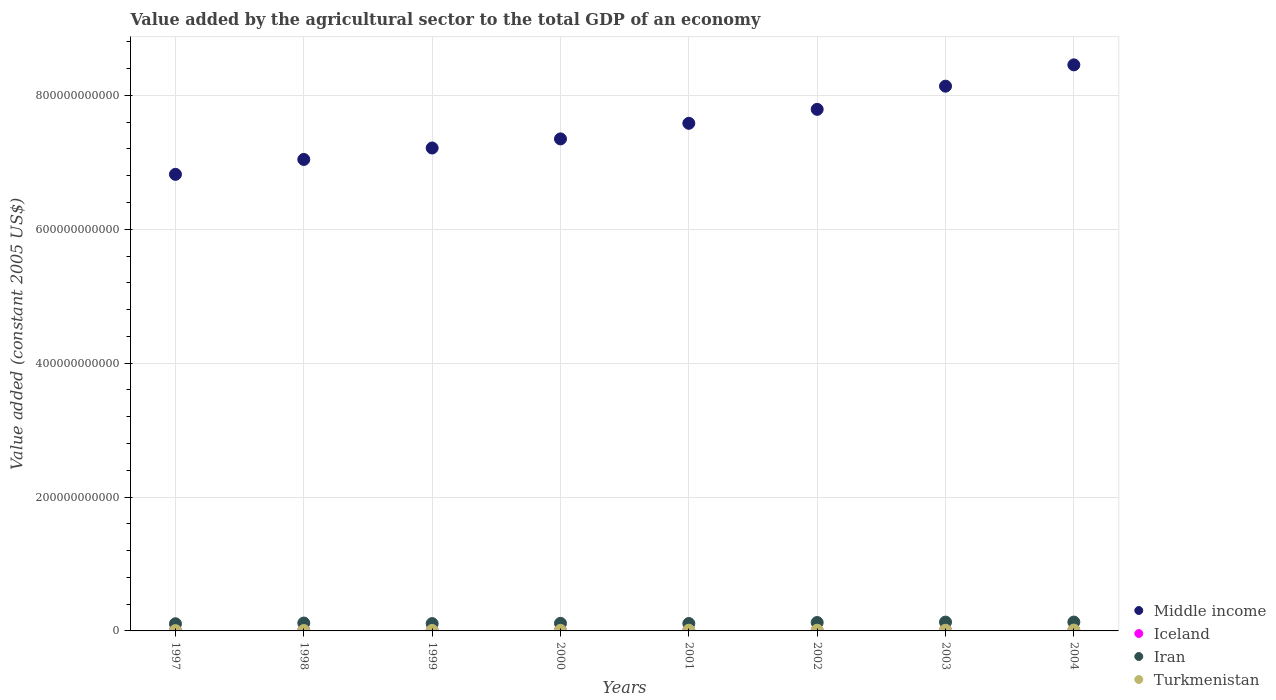How many different coloured dotlines are there?
Make the answer very short. 4. Is the number of dotlines equal to the number of legend labels?
Your answer should be very brief. Yes. What is the value added by the agricultural sector in Turkmenistan in 1999?
Provide a short and direct response. 7.26e+08. Across all years, what is the maximum value added by the agricultural sector in Middle income?
Your answer should be very brief. 8.46e+11. Across all years, what is the minimum value added by the agricultural sector in Iceland?
Your answer should be very brief. 7.81e+08. In which year was the value added by the agricultural sector in Iceland minimum?
Provide a succinct answer. 2000. What is the total value added by the agricultural sector in Turkmenistan in the graph?
Give a very brief answer. 7.00e+09. What is the difference between the value added by the agricultural sector in Iran in 1997 and that in 2003?
Offer a very short reply. -2.51e+09. What is the difference between the value added by the agricultural sector in Turkmenistan in 1998 and the value added by the agricultural sector in Iran in 2000?
Ensure brevity in your answer.  -1.07e+1. What is the average value added by the agricultural sector in Turkmenistan per year?
Your answer should be compact. 8.75e+08. In the year 2000, what is the difference between the value added by the agricultural sector in Iran and value added by the agricultural sector in Turkmenistan?
Your answer should be compact. 1.05e+1. In how many years, is the value added by the agricultural sector in Iceland greater than 480000000000 US$?
Keep it short and to the point. 0. What is the ratio of the value added by the agricultural sector in Turkmenistan in 1997 to that in 2001?
Ensure brevity in your answer.  0.45. What is the difference between the highest and the second highest value added by the agricultural sector in Iran?
Your answer should be very brief. 4.16e+07. What is the difference between the highest and the lowest value added by the agricultural sector in Iceland?
Your answer should be very brief. 8.22e+07. In how many years, is the value added by the agricultural sector in Iran greater than the average value added by the agricultural sector in Iran taken over all years?
Your answer should be very brief. 3. Is the sum of the value added by the agricultural sector in Iran in 1998 and 2003 greater than the maximum value added by the agricultural sector in Middle income across all years?
Give a very brief answer. No. Is it the case that in every year, the sum of the value added by the agricultural sector in Middle income and value added by the agricultural sector in Iceland  is greater than the sum of value added by the agricultural sector in Turkmenistan and value added by the agricultural sector in Iran?
Offer a very short reply. Yes. Is the value added by the agricultural sector in Iceland strictly greater than the value added by the agricultural sector in Turkmenistan over the years?
Provide a short and direct response. No. How many dotlines are there?
Offer a very short reply. 4. How many years are there in the graph?
Make the answer very short. 8. What is the difference between two consecutive major ticks on the Y-axis?
Offer a very short reply. 2.00e+11. Are the values on the major ticks of Y-axis written in scientific E-notation?
Provide a succinct answer. No. Where does the legend appear in the graph?
Provide a short and direct response. Bottom right. How many legend labels are there?
Your answer should be compact. 4. What is the title of the graph?
Keep it short and to the point. Value added by the agricultural sector to the total GDP of an economy. What is the label or title of the Y-axis?
Ensure brevity in your answer.  Value added (constant 2005 US$). What is the Value added (constant 2005 US$) of Middle income in 1997?
Make the answer very short. 6.82e+11. What is the Value added (constant 2005 US$) in Iceland in 1997?
Keep it short and to the point. 8.63e+08. What is the Value added (constant 2005 US$) in Iran in 1997?
Your response must be concise. 1.07e+1. What is the Value added (constant 2005 US$) in Turkmenistan in 1997?
Provide a succinct answer. 4.65e+08. What is the Value added (constant 2005 US$) of Middle income in 1998?
Your answer should be compact. 7.04e+11. What is the Value added (constant 2005 US$) of Iceland in 1998?
Ensure brevity in your answer.  8.18e+08. What is the Value added (constant 2005 US$) of Iran in 1998?
Ensure brevity in your answer.  1.18e+1. What is the Value added (constant 2005 US$) in Turkmenistan in 1998?
Your response must be concise. 5.78e+08. What is the Value added (constant 2005 US$) in Middle income in 1999?
Give a very brief answer. 7.21e+11. What is the Value added (constant 2005 US$) in Iceland in 1999?
Provide a short and direct response. 7.97e+08. What is the Value added (constant 2005 US$) of Iran in 1999?
Give a very brief answer. 1.09e+1. What is the Value added (constant 2005 US$) in Turkmenistan in 1999?
Your answer should be compact. 7.26e+08. What is the Value added (constant 2005 US$) of Middle income in 2000?
Offer a terse response. 7.35e+11. What is the Value added (constant 2005 US$) of Iceland in 2000?
Offer a very short reply. 7.81e+08. What is the Value added (constant 2005 US$) in Iran in 2000?
Provide a short and direct response. 1.13e+1. What is the Value added (constant 2005 US$) in Turkmenistan in 2000?
Provide a short and direct response. 8.49e+08. What is the Value added (constant 2005 US$) in Middle income in 2001?
Provide a short and direct response. 7.58e+11. What is the Value added (constant 2005 US$) in Iceland in 2001?
Your answer should be very brief. 7.92e+08. What is the Value added (constant 2005 US$) of Iran in 2001?
Your answer should be very brief. 1.11e+1. What is the Value added (constant 2005 US$) of Turkmenistan in 2001?
Offer a very short reply. 1.04e+09. What is the Value added (constant 2005 US$) of Middle income in 2002?
Ensure brevity in your answer.  7.79e+11. What is the Value added (constant 2005 US$) of Iceland in 2002?
Keep it short and to the point. 8.12e+08. What is the Value added (constant 2005 US$) of Iran in 2002?
Offer a very short reply. 1.26e+1. What is the Value added (constant 2005 US$) of Turkmenistan in 2002?
Offer a terse response. 1.05e+09. What is the Value added (constant 2005 US$) in Middle income in 2003?
Provide a succinct answer. 8.14e+11. What is the Value added (constant 2005 US$) in Iceland in 2003?
Provide a short and direct response. 7.88e+08. What is the Value added (constant 2005 US$) in Iran in 2003?
Ensure brevity in your answer.  1.32e+1. What is the Value added (constant 2005 US$) of Turkmenistan in 2003?
Your answer should be very brief. 1.05e+09. What is the Value added (constant 2005 US$) of Middle income in 2004?
Give a very brief answer. 8.46e+11. What is the Value added (constant 2005 US$) of Iceland in 2004?
Provide a short and direct response. 8.17e+08. What is the Value added (constant 2005 US$) of Iran in 2004?
Provide a short and direct response. 1.32e+1. What is the Value added (constant 2005 US$) of Turkmenistan in 2004?
Provide a short and direct response. 1.25e+09. Across all years, what is the maximum Value added (constant 2005 US$) in Middle income?
Offer a terse response. 8.46e+11. Across all years, what is the maximum Value added (constant 2005 US$) of Iceland?
Your answer should be very brief. 8.63e+08. Across all years, what is the maximum Value added (constant 2005 US$) in Iran?
Ensure brevity in your answer.  1.32e+1. Across all years, what is the maximum Value added (constant 2005 US$) in Turkmenistan?
Provide a short and direct response. 1.25e+09. Across all years, what is the minimum Value added (constant 2005 US$) in Middle income?
Provide a succinct answer. 6.82e+11. Across all years, what is the minimum Value added (constant 2005 US$) in Iceland?
Make the answer very short. 7.81e+08. Across all years, what is the minimum Value added (constant 2005 US$) in Iran?
Your answer should be compact. 1.07e+1. Across all years, what is the minimum Value added (constant 2005 US$) in Turkmenistan?
Ensure brevity in your answer.  4.65e+08. What is the total Value added (constant 2005 US$) in Middle income in the graph?
Keep it short and to the point. 6.04e+12. What is the total Value added (constant 2005 US$) of Iceland in the graph?
Make the answer very short. 6.47e+09. What is the total Value added (constant 2005 US$) of Iran in the graph?
Give a very brief answer. 9.48e+1. What is the total Value added (constant 2005 US$) in Turkmenistan in the graph?
Your response must be concise. 7.00e+09. What is the difference between the Value added (constant 2005 US$) of Middle income in 1997 and that in 1998?
Make the answer very short. -2.23e+1. What is the difference between the Value added (constant 2005 US$) in Iceland in 1997 and that in 1998?
Make the answer very short. 4.45e+07. What is the difference between the Value added (constant 2005 US$) in Iran in 1997 and that in 1998?
Provide a short and direct response. -1.13e+09. What is the difference between the Value added (constant 2005 US$) in Turkmenistan in 1997 and that in 1998?
Provide a short and direct response. -1.13e+08. What is the difference between the Value added (constant 2005 US$) in Middle income in 1997 and that in 1999?
Offer a very short reply. -3.94e+1. What is the difference between the Value added (constant 2005 US$) in Iceland in 1997 and that in 1999?
Keep it short and to the point. 6.59e+07. What is the difference between the Value added (constant 2005 US$) of Iran in 1997 and that in 1999?
Offer a very short reply. -2.66e+08. What is the difference between the Value added (constant 2005 US$) of Turkmenistan in 1997 and that in 1999?
Keep it short and to the point. -2.61e+08. What is the difference between the Value added (constant 2005 US$) of Middle income in 1997 and that in 2000?
Your response must be concise. -5.30e+1. What is the difference between the Value added (constant 2005 US$) in Iceland in 1997 and that in 2000?
Keep it short and to the point. 8.22e+07. What is the difference between the Value added (constant 2005 US$) in Iran in 1997 and that in 2000?
Make the answer very short. -6.46e+08. What is the difference between the Value added (constant 2005 US$) of Turkmenistan in 1997 and that in 2000?
Offer a very short reply. -3.84e+08. What is the difference between the Value added (constant 2005 US$) of Middle income in 1997 and that in 2001?
Offer a very short reply. -7.62e+1. What is the difference between the Value added (constant 2005 US$) of Iceland in 1997 and that in 2001?
Provide a short and direct response. 7.13e+07. What is the difference between the Value added (constant 2005 US$) in Iran in 1997 and that in 2001?
Ensure brevity in your answer.  -3.90e+08. What is the difference between the Value added (constant 2005 US$) in Turkmenistan in 1997 and that in 2001?
Ensure brevity in your answer.  -5.80e+08. What is the difference between the Value added (constant 2005 US$) in Middle income in 1997 and that in 2002?
Offer a very short reply. -9.71e+1. What is the difference between the Value added (constant 2005 US$) of Iceland in 1997 and that in 2002?
Your answer should be very brief. 5.09e+07. What is the difference between the Value added (constant 2005 US$) of Iran in 1997 and that in 2002?
Keep it short and to the point. -1.89e+09. What is the difference between the Value added (constant 2005 US$) of Turkmenistan in 1997 and that in 2002?
Your response must be concise. -5.81e+08. What is the difference between the Value added (constant 2005 US$) of Middle income in 1997 and that in 2003?
Provide a succinct answer. -1.32e+11. What is the difference between the Value added (constant 2005 US$) in Iceland in 1997 and that in 2003?
Offer a terse response. 7.52e+07. What is the difference between the Value added (constant 2005 US$) in Iran in 1997 and that in 2003?
Ensure brevity in your answer.  -2.51e+09. What is the difference between the Value added (constant 2005 US$) of Turkmenistan in 1997 and that in 2003?
Provide a short and direct response. -5.82e+08. What is the difference between the Value added (constant 2005 US$) in Middle income in 1997 and that in 2004?
Ensure brevity in your answer.  -1.64e+11. What is the difference between the Value added (constant 2005 US$) of Iceland in 1997 and that in 2004?
Ensure brevity in your answer.  4.60e+07. What is the difference between the Value added (constant 2005 US$) in Iran in 1997 and that in 2004?
Your response must be concise. -2.55e+09. What is the difference between the Value added (constant 2005 US$) in Turkmenistan in 1997 and that in 2004?
Your answer should be compact. -7.84e+08. What is the difference between the Value added (constant 2005 US$) of Middle income in 1998 and that in 1999?
Keep it short and to the point. -1.71e+1. What is the difference between the Value added (constant 2005 US$) of Iceland in 1998 and that in 1999?
Your response must be concise. 2.15e+07. What is the difference between the Value added (constant 2005 US$) of Iran in 1998 and that in 1999?
Your answer should be compact. 8.62e+08. What is the difference between the Value added (constant 2005 US$) in Turkmenistan in 1998 and that in 1999?
Offer a terse response. -1.47e+08. What is the difference between the Value added (constant 2005 US$) in Middle income in 1998 and that in 2000?
Offer a very short reply. -3.07e+1. What is the difference between the Value added (constant 2005 US$) of Iceland in 1998 and that in 2000?
Ensure brevity in your answer.  3.77e+07. What is the difference between the Value added (constant 2005 US$) in Iran in 1998 and that in 2000?
Your answer should be very brief. 4.82e+08. What is the difference between the Value added (constant 2005 US$) of Turkmenistan in 1998 and that in 2000?
Ensure brevity in your answer.  -2.71e+08. What is the difference between the Value added (constant 2005 US$) of Middle income in 1998 and that in 2001?
Offer a very short reply. -5.40e+1. What is the difference between the Value added (constant 2005 US$) in Iceland in 1998 and that in 2001?
Your answer should be very brief. 2.68e+07. What is the difference between the Value added (constant 2005 US$) in Iran in 1998 and that in 2001?
Provide a succinct answer. 7.38e+08. What is the difference between the Value added (constant 2005 US$) in Turkmenistan in 1998 and that in 2001?
Offer a very short reply. -4.66e+08. What is the difference between the Value added (constant 2005 US$) of Middle income in 1998 and that in 2002?
Your answer should be very brief. -7.48e+1. What is the difference between the Value added (constant 2005 US$) in Iceland in 1998 and that in 2002?
Make the answer very short. 6.42e+06. What is the difference between the Value added (constant 2005 US$) of Iran in 1998 and that in 2002?
Keep it short and to the point. -7.62e+08. What is the difference between the Value added (constant 2005 US$) of Turkmenistan in 1998 and that in 2002?
Provide a succinct answer. -4.67e+08. What is the difference between the Value added (constant 2005 US$) in Middle income in 1998 and that in 2003?
Make the answer very short. -1.09e+11. What is the difference between the Value added (constant 2005 US$) of Iceland in 1998 and that in 2003?
Offer a very short reply. 3.08e+07. What is the difference between the Value added (constant 2005 US$) in Iran in 1998 and that in 2003?
Keep it short and to the point. -1.38e+09. What is the difference between the Value added (constant 2005 US$) of Turkmenistan in 1998 and that in 2003?
Ensure brevity in your answer.  -4.68e+08. What is the difference between the Value added (constant 2005 US$) of Middle income in 1998 and that in 2004?
Offer a terse response. -1.41e+11. What is the difference between the Value added (constant 2005 US$) in Iceland in 1998 and that in 2004?
Offer a very short reply. 1.51e+06. What is the difference between the Value added (constant 2005 US$) in Iran in 1998 and that in 2004?
Keep it short and to the point. -1.43e+09. What is the difference between the Value added (constant 2005 US$) in Turkmenistan in 1998 and that in 2004?
Keep it short and to the point. -6.70e+08. What is the difference between the Value added (constant 2005 US$) of Middle income in 1999 and that in 2000?
Provide a succinct answer. -1.36e+1. What is the difference between the Value added (constant 2005 US$) of Iceland in 1999 and that in 2000?
Give a very brief answer. 1.63e+07. What is the difference between the Value added (constant 2005 US$) of Iran in 1999 and that in 2000?
Make the answer very short. -3.80e+08. What is the difference between the Value added (constant 2005 US$) in Turkmenistan in 1999 and that in 2000?
Ensure brevity in your answer.  -1.23e+08. What is the difference between the Value added (constant 2005 US$) of Middle income in 1999 and that in 2001?
Offer a very short reply. -3.69e+1. What is the difference between the Value added (constant 2005 US$) of Iceland in 1999 and that in 2001?
Ensure brevity in your answer.  5.39e+06. What is the difference between the Value added (constant 2005 US$) in Iran in 1999 and that in 2001?
Give a very brief answer. -1.24e+08. What is the difference between the Value added (constant 2005 US$) in Turkmenistan in 1999 and that in 2001?
Ensure brevity in your answer.  -3.19e+08. What is the difference between the Value added (constant 2005 US$) of Middle income in 1999 and that in 2002?
Provide a short and direct response. -5.77e+1. What is the difference between the Value added (constant 2005 US$) of Iceland in 1999 and that in 2002?
Ensure brevity in your answer.  -1.50e+07. What is the difference between the Value added (constant 2005 US$) of Iran in 1999 and that in 2002?
Keep it short and to the point. -1.62e+09. What is the difference between the Value added (constant 2005 US$) of Turkmenistan in 1999 and that in 2002?
Keep it short and to the point. -3.20e+08. What is the difference between the Value added (constant 2005 US$) in Middle income in 1999 and that in 2003?
Offer a terse response. -9.24e+1. What is the difference between the Value added (constant 2005 US$) in Iceland in 1999 and that in 2003?
Keep it short and to the point. 9.34e+06. What is the difference between the Value added (constant 2005 US$) of Iran in 1999 and that in 2003?
Provide a succinct answer. -2.25e+09. What is the difference between the Value added (constant 2005 US$) in Turkmenistan in 1999 and that in 2003?
Make the answer very short. -3.21e+08. What is the difference between the Value added (constant 2005 US$) of Middle income in 1999 and that in 2004?
Provide a succinct answer. -1.24e+11. What is the difference between the Value added (constant 2005 US$) of Iceland in 1999 and that in 2004?
Provide a succinct answer. -1.99e+07. What is the difference between the Value added (constant 2005 US$) of Iran in 1999 and that in 2004?
Ensure brevity in your answer.  -2.29e+09. What is the difference between the Value added (constant 2005 US$) of Turkmenistan in 1999 and that in 2004?
Your response must be concise. -5.23e+08. What is the difference between the Value added (constant 2005 US$) in Middle income in 2000 and that in 2001?
Your answer should be compact. -2.33e+1. What is the difference between the Value added (constant 2005 US$) of Iceland in 2000 and that in 2001?
Make the answer very short. -1.09e+07. What is the difference between the Value added (constant 2005 US$) of Iran in 2000 and that in 2001?
Keep it short and to the point. 2.56e+08. What is the difference between the Value added (constant 2005 US$) of Turkmenistan in 2000 and that in 2001?
Your answer should be compact. -1.95e+08. What is the difference between the Value added (constant 2005 US$) of Middle income in 2000 and that in 2002?
Your response must be concise. -4.41e+1. What is the difference between the Value added (constant 2005 US$) of Iceland in 2000 and that in 2002?
Provide a short and direct response. -3.13e+07. What is the difference between the Value added (constant 2005 US$) in Iran in 2000 and that in 2002?
Your answer should be very brief. -1.24e+09. What is the difference between the Value added (constant 2005 US$) in Turkmenistan in 2000 and that in 2002?
Your answer should be compact. -1.96e+08. What is the difference between the Value added (constant 2005 US$) of Middle income in 2000 and that in 2003?
Give a very brief answer. -7.88e+1. What is the difference between the Value added (constant 2005 US$) in Iceland in 2000 and that in 2003?
Keep it short and to the point. -6.94e+06. What is the difference between the Value added (constant 2005 US$) in Iran in 2000 and that in 2003?
Offer a very short reply. -1.87e+09. What is the difference between the Value added (constant 2005 US$) in Turkmenistan in 2000 and that in 2003?
Keep it short and to the point. -1.97e+08. What is the difference between the Value added (constant 2005 US$) of Middle income in 2000 and that in 2004?
Your answer should be very brief. -1.11e+11. What is the difference between the Value added (constant 2005 US$) in Iceland in 2000 and that in 2004?
Offer a very short reply. -3.62e+07. What is the difference between the Value added (constant 2005 US$) in Iran in 2000 and that in 2004?
Your answer should be compact. -1.91e+09. What is the difference between the Value added (constant 2005 US$) in Turkmenistan in 2000 and that in 2004?
Your answer should be very brief. -3.99e+08. What is the difference between the Value added (constant 2005 US$) in Middle income in 2001 and that in 2002?
Offer a very short reply. -2.08e+1. What is the difference between the Value added (constant 2005 US$) in Iceland in 2001 and that in 2002?
Make the answer very short. -2.04e+07. What is the difference between the Value added (constant 2005 US$) of Iran in 2001 and that in 2002?
Give a very brief answer. -1.50e+09. What is the difference between the Value added (constant 2005 US$) in Turkmenistan in 2001 and that in 2002?
Provide a short and direct response. -9.92e+05. What is the difference between the Value added (constant 2005 US$) of Middle income in 2001 and that in 2003?
Provide a succinct answer. -5.55e+1. What is the difference between the Value added (constant 2005 US$) in Iceland in 2001 and that in 2003?
Your response must be concise. 3.95e+06. What is the difference between the Value added (constant 2005 US$) in Iran in 2001 and that in 2003?
Offer a terse response. -2.12e+09. What is the difference between the Value added (constant 2005 US$) in Turkmenistan in 2001 and that in 2003?
Offer a very short reply. -2.03e+06. What is the difference between the Value added (constant 2005 US$) of Middle income in 2001 and that in 2004?
Your response must be concise. -8.73e+1. What is the difference between the Value added (constant 2005 US$) in Iceland in 2001 and that in 2004?
Make the answer very short. -2.53e+07. What is the difference between the Value added (constant 2005 US$) of Iran in 2001 and that in 2004?
Your answer should be compact. -2.16e+09. What is the difference between the Value added (constant 2005 US$) of Turkmenistan in 2001 and that in 2004?
Provide a succinct answer. -2.04e+08. What is the difference between the Value added (constant 2005 US$) in Middle income in 2002 and that in 2003?
Provide a succinct answer. -3.46e+1. What is the difference between the Value added (constant 2005 US$) of Iceland in 2002 and that in 2003?
Offer a very short reply. 2.44e+07. What is the difference between the Value added (constant 2005 US$) in Iran in 2002 and that in 2003?
Ensure brevity in your answer.  -6.22e+08. What is the difference between the Value added (constant 2005 US$) of Turkmenistan in 2002 and that in 2003?
Provide a succinct answer. -1.03e+06. What is the difference between the Value added (constant 2005 US$) of Middle income in 2002 and that in 2004?
Your answer should be very brief. -6.64e+1. What is the difference between the Value added (constant 2005 US$) of Iceland in 2002 and that in 2004?
Offer a very short reply. -4.91e+06. What is the difference between the Value added (constant 2005 US$) in Iran in 2002 and that in 2004?
Ensure brevity in your answer.  -6.64e+08. What is the difference between the Value added (constant 2005 US$) of Turkmenistan in 2002 and that in 2004?
Offer a very short reply. -2.03e+08. What is the difference between the Value added (constant 2005 US$) of Middle income in 2003 and that in 2004?
Keep it short and to the point. -3.18e+1. What is the difference between the Value added (constant 2005 US$) of Iceland in 2003 and that in 2004?
Provide a short and direct response. -2.93e+07. What is the difference between the Value added (constant 2005 US$) in Iran in 2003 and that in 2004?
Ensure brevity in your answer.  -4.16e+07. What is the difference between the Value added (constant 2005 US$) of Turkmenistan in 2003 and that in 2004?
Offer a terse response. -2.02e+08. What is the difference between the Value added (constant 2005 US$) in Middle income in 1997 and the Value added (constant 2005 US$) in Iceland in 1998?
Give a very brief answer. 6.81e+11. What is the difference between the Value added (constant 2005 US$) of Middle income in 1997 and the Value added (constant 2005 US$) of Iran in 1998?
Provide a succinct answer. 6.70e+11. What is the difference between the Value added (constant 2005 US$) of Middle income in 1997 and the Value added (constant 2005 US$) of Turkmenistan in 1998?
Keep it short and to the point. 6.81e+11. What is the difference between the Value added (constant 2005 US$) in Iceland in 1997 and the Value added (constant 2005 US$) in Iran in 1998?
Keep it short and to the point. -1.09e+1. What is the difference between the Value added (constant 2005 US$) in Iceland in 1997 and the Value added (constant 2005 US$) in Turkmenistan in 1998?
Offer a very short reply. 2.85e+08. What is the difference between the Value added (constant 2005 US$) in Iran in 1997 and the Value added (constant 2005 US$) in Turkmenistan in 1998?
Provide a succinct answer. 1.01e+1. What is the difference between the Value added (constant 2005 US$) in Middle income in 1997 and the Value added (constant 2005 US$) in Iceland in 1999?
Keep it short and to the point. 6.81e+11. What is the difference between the Value added (constant 2005 US$) in Middle income in 1997 and the Value added (constant 2005 US$) in Iran in 1999?
Give a very brief answer. 6.71e+11. What is the difference between the Value added (constant 2005 US$) in Middle income in 1997 and the Value added (constant 2005 US$) in Turkmenistan in 1999?
Keep it short and to the point. 6.81e+11. What is the difference between the Value added (constant 2005 US$) in Iceland in 1997 and the Value added (constant 2005 US$) in Iran in 1999?
Provide a short and direct response. -1.01e+1. What is the difference between the Value added (constant 2005 US$) in Iceland in 1997 and the Value added (constant 2005 US$) in Turkmenistan in 1999?
Offer a terse response. 1.37e+08. What is the difference between the Value added (constant 2005 US$) in Iran in 1997 and the Value added (constant 2005 US$) in Turkmenistan in 1999?
Provide a short and direct response. 9.95e+09. What is the difference between the Value added (constant 2005 US$) in Middle income in 1997 and the Value added (constant 2005 US$) in Iceland in 2000?
Your response must be concise. 6.81e+11. What is the difference between the Value added (constant 2005 US$) in Middle income in 1997 and the Value added (constant 2005 US$) in Iran in 2000?
Provide a short and direct response. 6.71e+11. What is the difference between the Value added (constant 2005 US$) of Middle income in 1997 and the Value added (constant 2005 US$) of Turkmenistan in 2000?
Give a very brief answer. 6.81e+11. What is the difference between the Value added (constant 2005 US$) in Iceland in 1997 and the Value added (constant 2005 US$) in Iran in 2000?
Provide a succinct answer. -1.05e+1. What is the difference between the Value added (constant 2005 US$) in Iceland in 1997 and the Value added (constant 2005 US$) in Turkmenistan in 2000?
Your response must be concise. 1.37e+07. What is the difference between the Value added (constant 2005 US$) in Iran in 1997 and the Value added (constant 2005 US$) in Turkmenistan in 2000?
Your response must be concise. 9.83e+09. What is the difference between the Value added (constant 2005 US$) of Middle income in 1997 and the Value added (constant 2005 US$) of Iceland in 2001?
Provide a succinct answer. 6.81e+11. What is the difference between the Value added (constant 2005 US$) in Middle income in 1997 and the Value added (constant 2005 US$) in Iran in 2001?
Provide a short and direct response. 6.71e+11. What is the difference between the Value added (constant 2005 US$) in Middle income in 1997 and the Value added (constant 2005 US$) in Turkmenistan in 2001?
Make the answer very short. 6.81e+11. What is the difference between the Value added (constant 2005 US$) of Iceland in 1997 and the Value added (constant 2005 US$) of Iran in 2001?
Offer a very short reply. -1.02e+1. What is the difference between the Value added (constant 2005 US$) of Iceland in 1997 and the Value added (constant 2005 US$) of Turkmenistan in 2001?
Offer a terse response. -1.82e+08. What is the difference between the Value added (constant 2005 US$) of Iran in 1997 and the Value added (constant 2005 US$) of Turkmenistan in 2001?
Give a very brief answer. 9.63e+09. What is the difference between the Value added (constant 2005 US$) in Middle income in 1997 and the Value added (constant 2005 US$) in Iceland in 2002?
Provide a succinct answer. 6.81e+11. What is the difference between the Value added (constant 2005 US$) in Middle income in 1997 and the Value added (constant 2005 US$) in Iran in 2002?
Ensure brevity in your answer.  6.69e+11. What is the difference between the Value added (constant 2005 US$) in Middle income in 1997 and the Value added (constant 2005 US$) in Turkmenistan in 2002?
Offer a terse response. 6.81e+11. What is the difference between the Value added (constant 2005 US$) of Iceland in 1997 and the Value added (constant 2005 US$) of Iran in 2002?
Offer a very short reply. -1.17e+1. What is the difference between the Value added (constant 2005 US$) in Iceland in 1997 and the Value added (constant 2005 US$) in Turkmenistan in 2002?
Your answer should be very brief. -1.83e+08. What is the difference between the Value added (constant 2005 US$) in Iran in 1997 and the Value added (constant 2005 US$) in Turkmenistan in 2002?
Provide a succinct answer. 9.63e+09. What is the difference between the Value added (constant 2005 US$) in Middle income in 1997 and the Value added (constant 2005 US$) in Iceland in 2003?
Give a very brief answer. 6.81e+11. What is the difference between the Value added (constant 2005 US$) of Middle income in 1997 and the Value added (constant 2005 US$) of Iran in 2003?
Your answer should be very brief. 6.69e+11. What is the difference between the Value added (constant 2005 US$) in Middle income in 1997 and the Value added (constant 2005 US$) in Turkmenistan in 2003?
Ensure brevity in your answer.  6.81e+11. What is the difference between the Value added (constant 2005 US$) in Iceland in 1997 and the Value added (constant 2005 US$) in Iran in 2003?
Make the answer very short. -1.23e+1. What is the difference between the Value added (constant 2005 US$) in Iceland in 1997 and the Value added (constant 2005 US$) in Turkmenistan in 2003?
Ensure brevity in your answer.  -1.84e+08. What is the difference between the Value added (constant 2005 US$) in Iran in 1997 and the Value added (constant 2005 US$) in Turkmenistan in 2003?
Ensure brevity in your answer.  9.63e+09. What is the difference between the Value added (constant 2005 US$) in Middle income in 1997 and the Value added (constant 2005 US$) in Iceland in 2004?
Give a very brief answer. 6.81e+11. What is the difference between the Value added (constant 2005 US$) of Middle income in 1997 and the Value added (constant 2005 US$) of Iran in 2004?
Offer a terse response. 6.69e+11. What is the difference between the Value added (constant 2005 US$) in Middle income in 1997 and the Value added (constant 2005 US$) in Turkmenistan in 2004?
Offer a very short reply. 6.81e+11. What is the difference between the Value added (constant 2005 US$) of Iceland in 1997 and the Value added (constant 2005 US$) of Iran in 2004?
Make the answer very short. -1.24e+1. What is the difference between the Value added (constant 2005 US$) of Iceland in 1997 and the Value added (constant 2005 US$) of Turkmenistan in 2004?
Provide a short and direct response. -3.86e+08. What is the difference between the Value added (constant 2005 US$) of Iran in 1997 and the Value added (constant 2005 US$) of Turkmenistan in 2004?
Offer a very short reply. 9.43e+09. What is the difference between the Value added (constant 2005 US$) in Middle income in 1998 and the Value added (constant 2005 US$) in Iceland in 1999?
Your answer should be compact. 7.03e+11. What is the difference between the Value added (constant 2005 US$) of Middle income in 1998 and the Value added (constant 2005 US$) of Iran in 1999?
Ensure brevity in your answer.  6.93e+11. What is the difference between the Value added (constant 2005 US$) of Middle income in 1998 and the Value added (constant 2005 US$) of Turkmenistan in 1999?
Ensure brevity in your answer.  7.04e+11. What is the difference between the Value added (constant 2005 US$) of Iceland in 1998 and the Value added (constant 2005 US$) of Iran in 1999?
Your answer should be very brief. -1.01e+1. What is the difference between the Value added (constant 2005 US$) of Iceland in 1998 and the Value added (constant 2005 US$) of Turkmenistan in 1999?
Give a very brief answer. 9.27e+07. What is the difference between the Value added (constant 2005 US$) of Iran in 1998 and the Value added (constant 2005 US$) of Turkmenistan in 1999?
Offer a very short reply. 1.11e+1. What is the difference between the Value added (constant 2005 US$) of Middle income in 1998 and the Value added (constant 2005 US$) of Iceland in 2000?
Offer a terse response. 7.03e+11. What is the difference between the Value added (constant 2005 US$) of Middle income in 1998 and the Value added (constant 2005 US$) of Iran in 2000?
Provide a succinct answer. 6.93e+11. What is the difference between the Value added (constant 2005 US$) in Middle income in 1998 and the Value added (constant 2005 US$) in Turkmenistan in 2000?
Make the answer very short. 7.03e+11. What is the difference between the Value added (constant 2005 US$) of Iceland in 1998 and the Value added (constant 2005 US$) of Iran in 2000?
Provide a succinct answer. -1.05e+1. What is the difference between the Value added (constant 2005 US$) in Iceland in 1998 and the Value added (constant 2005 US$) in Turkmenistan in 2000?
Make the answer very short. -3.07e+07. What is the difference between the Value added (constant 2005 US$) in Iran in 1998 and the Value added (constant 2005 US$) in Turkmenistan in 2000?
Your answer should be very brief. 1.10e+1. What is the difference between the Value added (constant 2005 US$) of Middle income in 1998 and the Value added (constant 2005 US$) of Iceland in 2001?
Offer a very short reply. 7.03e+11. What is the difference between the Value added (constant 2005 US$) in Middle income in 1998 and the Value added (constant 2005 US$) in Iran in 2001?
Offer a terse response. 6.93e+11. What is the difference between the Value added (constant 2005 US$) of Middle income in 1998 and the Value added (constant 2005 US$) of Turkmenistan in 2001?
Keep it short and to the point. 7.03e+11. What is the difference between the Value added (constant 2005 US$) of Iceland in 1998 and the Value added (constant 2005 US$) of Iran in 2001?
Give a very brief answer. -1.02e+1. What is the difference between the Value added (constant 2005 US$) of Iceland in 1998 and the Value added (constant 2005 US$) of Turkmenistan in 2001?
Give a very brief answer. -2.26e+08. What is the difference between the Value added (constant 2005 US$) in Iran in 1998 and the Value added (constant 2005 US$) in Turkmenistan in 2001?
Give a very brief answer. 1.08e+1. What is the difference between the Value added (constant 2005 US$) in Middle income in 1998 and the Value added (constant 2005 US$) in Iceland in 2002?
Make the answer very short. 7.03e+11. What is the difference between the Value added (constant 2005 US$) of Middle income in 1998 and the Value added (constant 2005 US$) of Iran in 2002?
Give a very brief answer. 6.92e+11. What is the difference between the Value added (constant 2005 US$) of Middle income in 1998 and the Value added (constant 2005 US$) of Turkmenistan in 2002?
Ensure brevity in your answer.  7.03e+11. What is the difference between the Value added (constant 2005 US$) of Iceland in 1998 and the Value added (constant 2005 US$) of Iran in 2002?
Your answer should be very brief. -1.17e+1. What is the difference between the Value added (constant 2005 US$) of Iceland in 1998 and the Value added (constant 2005 US$) of Turkmenistan in 2002?
Ensure brevity in your answer.  -2.27e+08. What is the difference between the Value added (constant 2005 US$) of Iran in 1998 and the Value added (constant 2005 US$) of Turkmenistan in 2002?
Give a very brief answer. 1.08e+1. What is the difference between the Value added (constant 2005 US$) in Middle income in 1998 and the Value added (constant 2005 US$) in Iceland in 2003?
Offer a terse response. 7.03e+11. What is the difference between the Value added (constant 2005 US$) in Middle income in 1998 and the Value added (constant 2005 US$) in Iran in 2003?
Offer a very short reply. 6.91e+11. What is the difference between the Value added (constant 2005 US$) in Middle income in 1998 and the Value added (constant 2005 US$) in Turkmenistan in 2003?
Your answer should be very brief. 7.03e+11. What is the difference between the Value added (constant 2005 US$) of Iceland in 1998 and the Value added (constant 2005 US$) of Iran in 2003?
Make the answer very short. -1.24e+1. What is the difference between the Value added (constant 2005 US$) in Iceland in 1998 and the Value added (constant 2005 US$) in Turkmenistan in 2003?
Provide a short and direct response. -2.28e+08. What is the difference between the Value added (constant 2005 US$) of Iran in 1998 and the Value added (constant 2005 US$) of Turkmenistan in 2003?
Provide a succinct answer. 1.08e+1. What is the difference between the Value added (constant 2005 US$) in Middle income in 1998 and the Value added (constant 2005 US$) in Iceland in 2004?
Make the answer very short. 7.03e+11. What is the difference between the Value added (constant 2005 US$) in Middle income in 1998 and the Value added (constant 2005 US$) in Iran in 2004?
Provide a succinct answer. 6.91e+11. What is the difference between the Value added (constant 2005 US$) in Middle income in 1998 and the Value added (constant 2005 US$) in Turkmenistan in 2004?
Provide a short and direct response. 7.03e+11. What is the difference between the Value added (constant 2005 US$) of Iceland in 1998 and the Value added (constant 2005 US$) of Iran in 2004?
Your answer should be very brief. -1.24e+1. What is the difference between the Value added (constant 2005 US$) of Iceland in 1998 and the Value added (constant 2005 US$) of Turkmenistan in 2004?
Offer a terse response. -4.30e+08. What is the difference between the Value added (constant 2005 US$) of Iran in 1998 and the Value added (constant 2005 US$) of Turkmenistan in 2004?
Offer a terse response. 1.06e+1. What is the difference between the Value added (constant 2005 US$) of Middle income in 1999 and the Value added (constant 2005 US$) of Iceland in 2000?
Provide a succinct answer. 7.21e+11. What is the difference between the Value added (constant 2005 US$) in Middle income in 1999 and the Value added (constant 2005 US$) in Iran in 2000?
Your response must be concise. 7.10e+11. What is the difference between the Value added (constant 2005 US$) in Middle income in 1999 and the Value added (constant 2005 US$) in Turkmenistan in 2000?
Your answer should be compact. 7.20e+11. What is the difference between the Value added (constant 2005 US$) in Iceland in 1999 and the Value added (constant 2005 US$) in Iran in 2000?
Offer a very short reply. -1.05e+1. What is the difference between the Value added (constant 2005 US$) in Iceland in 1999 and the Value added (constant 2005 US$) in Turkmenistan in 2000?
Your response must be concise. -5.22e+07. What is the difference between the Value added (constant 2005 US$) of Iran in 1999 and the Value added (constant 2005 US$) of Turkmenistan in 2000?
Your answer should be compact. 1.01e+1. What is the difference between the Value added (constant 2005 US$) of Middle income in 1999 and the Value added (constant 2005 US$) of Iceland in 2001?
Ensure brevity in your answer.  7.21e+11. What is the difference between the Value added (constant 2005 US$) in Middle income in 1999 and the Value added (constant 2005 US$) in Iran in 2001?
Make the answer very short. 7.10e+11. What is the difference between the Value added (constant 2005 US$) in Middle income in 1999 and the Value added (constant 2005 US$) in Turkmenistan in 2001?
Offer a terse response. 7.20e+11. What is the difference between the Value added (constant 2005 US$) in Iceland in 1999 and the Value added (constant 2005 US$) in Iran in 2001?
Offer a terse response. -1.03e+1. What is the difference between the Value added (constant 2005 US$) in Iceland in 1999 and the Value added (constant 2005 US$) in Turkmenistan in 2001?
Your answer should be compact. -2.47e+08. What is the difference between the Value added (constant 2005 US$) of Iran in 1999 and the Value added (constant 2005 US$) of Turkmenistan in 2001?
Provide a succinct answer. 9.90e+09. What is the difference between the Value added (constant 2005 US$) in Middle income in 1999 and the Value added (constant 2005 US$) in Iceland in 2002?
Keep it short and to the point. 7.21e+11. What is the difference between the Value added (constant 2005 US$) of Middle income in 1999 and the Value added (constant 2005 US$) of Iran in 2002?
Give a very brief answer. 7.09e+11. What is the difference between the Value added (constant 2005 US$) in Middle income in 1999 and the Value added (constant 2005 US$) in Turkmenistan in 2002?
Your answer should be very brief. 7.20e+11. What is the difference between the Value added (constant 2005 US$) in Iceland in 1999 and the Value added (constant 2005 US$) in Iran in 2002?
Offer a terse response. -1.18e+1. What is the difference between the Value added (constant 2005 US$) in Iceland in 1999 and the Value added (constant 2005 US$) in Turkmenistan in 2002?
Your answer should be very brief. -2.48e+08. What is the difference between the Value added (constant 2005 US$) in Iran in 1999 and the Value added (constant 2005 US$) in Turkmenistan in 2002?
Offer a very short reply. 9.90e+09. What is the difference between the Value added (constant 2005 US$) of Middle income in 1999 and the Value added (constant 2005 US$) of Iceland in 2003?
Provide a short and direct response. 7.21e+11. What is the difference between the Value added (constant 2005 US$) of Middle income in 1999 and the Value added (constant 2005 US$) of Iran in 2003?
Your answer should be compact. 7.08e+11. What is the difference between the Value added (constant 2005 US$) of Middle income in 1999 and the Value added (constant 2005 US$) of Turkmenistan in 2003?
Make the answer very short. 7.20e+11. What is the difference between the Value added (constant 2005 US$) of Iceland in 1999 and the Value added (constant 2005 US$) of Iran in 2003?
Offer a terse response. -1.24e+1. What is the difference between the Value added (constant 2005 US$) in Iceland in 1999 and the Value added (constant 2005 US$) in Turkmenistan in 2003?
Your answer should be compact. -2.49e+08. What is the difference between the Value added (constant 2005 US$) of Iran in 1999 and the Value added (constant 2005 US$) of Turkmenistan in 2003?
Offer a very short reply. 9.90e+09. What is the difference between the Value added (constant 2005 US$) of Middle income in 1999 and the Value added (constant 2005 US$) of Iceland in 2004?
Offer a terse response. 7.21e+11. What is the difference between the Value added (constant 2005 US$) in Middle income in 1999 and the Value added (constant 2005 US$) in Iran in 2004?
Your response must be concise. 7.08e+11. What is the difference between the Value added (constant 2005 US$) of Middle income in 1999 and the Value added (constant 2005 US$) of Turkmenistan in 2004?
Make the answer very short. 7.20e+11. What is the difference between the Value added (constant 2005 US$) in Iceland in 1999 and the Value added (constant 2005 US$) in Iran in 2004?
Give a very brief answer. -1.24e+1. What is the difference between the Value added (constant 2005 US$) in Iceland in 1999 and the Value added (constant 2005 US$) in Turkmenistan in 2004?
Offer a terse response. -4.51e+08. What is the difference between the Value added (constant 2005 US$) in Iran in 1999 and the Value added (constant 2005 US$) in Turkmenistan in 2004?
Offer a terse response. 9.70e+09. What is the difference between the Value added (constant 2005 US$) in Middle income in 2000 and the Value added (constant 2005 US$) in Iceland in 2001?
Keep it short and to the point. 7.34e+11. What is the difference between the Value added (constant 2005 US$) in Middle income in 2000 and the Value added (constant 2005 US$) in Iran in 2001?
Give a very brief answer. 7.24e+11. What is the difference between the Value added (constant 2005 US$) in Middle income in 2000 and the Value added (constant 2005 US$) in Turkmenistan in 2001?
Your answer should be very brief. 7.34e+11. What is the difference between the Value added (constant 2005 US$) of Iceland in 2000 and the Value added (constant 2005 US$) of Iran in 2001?
Keep it short and to the point. -1.03e+1. What is the difference between the Value added (constant 2005 US$) in Iceland in 2000 and the Value added (constant 2005 US$) in Turkmenistan in 2001?
Keep it short and to the point. -2.64e+08. What is the difference between the Value added (constant 2005 US$) in Iran in 2000 and the Value added (constant 2005 US$) in Turkmenistan in 2001?
Give a very brief answer. 1.03e+1. What is the difference between the Value added (constant 2005 US$) in Middle income in 2000 and the Value added (constant 2005 US$) in Iceland in 2002?
Make the answer very short. 7.34e+11. What is the difference between the Value added (constant 2005 US$) of Middle income in 2000 and the Value added (constant 2005 US$) of Iran in 2002?
Make the answer very short. 7.22e+11. What is the difference between the Value added (constant 2005 US$) in Middle income in 2000 and the Value added (constant 2005 US$) in Turkmenistan in 2002?
Make the answer very short. 7.34e+11. What is the difference between the Value added (constant 2005 US$) in Iceland in 2000 and the Value added (constant 2005 US$) in Iran in 2002?
Offer a terse response. -1.18e+1. What is the difference between the Value added (constant 2005 US$) in Iceland in 2000 and the Value added (constant 2005 US$) in Turkmenistan in 2002?
Keep it short and to the point. -2.65e+08. What is the difference between the Value added (constant 2005 US$) in Iran in 2000 and the Value added (constant 2005 US$) in Turkmenistan in 2002?
Offer a terse response. 1.03e+1. What is the difference between the Value added (constant 2005 US$) in Middle income in 2000 and the Value added (constant 2005 US$) in Iceland in 2003?
Your response must be concise. 7.34e+11. What is the difference between the Value added (constant 2005 US$) of Middle income in 2000 and the Value added (constant 2005 US$) of Iran in 2003?
Provide a short and direct response. 7.22e+11. What is the difference between the Value added (constant 2005 US$) of Middle income in 2000 and the Value added (constant 2005 US$) of Turkmenistan in 2003?
Your answer should be compact. 7.34e+11. What is the difference between the Value added (constant 2005 US$) of Iceland in 2000 and the Value added (constant 2005 US$) of Iran in 2003?
Provide a short and direct response. -1.24e+1. What is the difference between the Value added (constant 2005 US$) of Iceland in 2000 and the Value added (constant 2005 US$) of Turkmenistan in 2003?
Provide a short and direct response. -2.66e+08. What is the difference between the Value added (constant 2005 US$) in Iran in 2000 and the Value added (constant 2005 US$) in Turkmenistan in 2003?
Ensure brevity in your answer.  1.03e+1. What is the difference between the Value added (constant 2005 US$) in Middle income in 2000 and the Value added (constant 2005 US$) in Iceland in 2004?
Provide a short and direct response. 7.34e+11. What is the difference between the Value added (constant 2005 US$) of Middle income in 2000 and the Value added (constant 2005 US$) of Iran in 2004?
Provide a short and direct response. 7.22e+11. What is the difference between the Value added (constant 2005 US$) in Middle income in 2000 and the Value added (constant 2005 US$) in Turkmenistan in 2004?
Keep it short and to the point. 7.34e+11. What is the difference between the Value added (constant 2005 US$) in Iceland in 2000 and the Value added (constant 2005 US$) in Iran in 2004?
Your answer should be compact. -1.25e+1. What is the difference between the Value added (constant 2005 US$) in Iceland in 2000 and the Value added (constant 2005 US$) in Turkmenistan in 2004?
Provide a succinct answer. -4.68e+08. What is the difference between the Value added (constant 2005 US$) in Iran in 2000 and the Value added (constant 2005 US$) in Turkmenistan in 2004?
Give a very brief answer. 1.01e+1. What is the difference between the Value added (constant 2005 US$) of Middle income in 2001 and the Value added (constant 2005 US$) of Iceland in 2002?
Make the answer very short. 7.57e+11. What is the difference between the Value added (constant 2005 US$) in Middle income in 2001 and the Value added (constant 2005 US$) in Iran in 2002?
Provide a short and direct response. 7.46e+11. What is the difference between the Value added (constant 2005 US$) of Middle income in 2001 and the Value added (constant 2005 US$) of Turkmenistan in 2002?
Keep it short and to the point. 7.57e+11. What is the difference between the Value added (constant 2005 US$) of Iceland in 2001 and the Value added (constant 2005 US$) of Iran in 2002?
Keep it short and to the point. -1.18e+1. What is the difference between the Value added (constant 2005 US$) in Iceland in 2001 and the Value added (constant 2005 US$) in Turkmenistan in 2002?
Ensure brevity in your answer.  -2.54e+08. What is the difference between the Value added (constant 2005 US$) in Iran in 2001 and the Value added (constant 2005 US$) in Turkmenistan in 2002?
Make the answer very short. 1.00e+1. What is the difference between the Value added (constant 2005 US$) of Middle income in 2001 and the Value added (constant 2005 US$) of Iceland in 2003?
Provide a short and direct response. 7.57e+11. What is the difference between the Value added (constant 2005 US$) of Middle income in 2001 and the Value added (constant 2005 US$) of Iran in 2003?
Provide a short and direct response. 7.45e+11. What is the difference between the Value added (constant 2005 US$) in Middle income in 2001 and the Value added (constant 2005 US$) in Turkmenistan in 2003?
Provide a short and direct response. 7.57e+11. What is the difference between the Value added (constant 2005 US$) in Iceland in 2001 and the Value added (constant 2005 US$) in Iran in 2003?
Give a very brief answer. -1.24e+1. What is the difference between the Value added (constant 2005 US$) in Iceland in 2001 and the Value added (constant 2005 US$) in Turkmenistan in 2003?
Offer a very short reply. -2.55e+08. What is the difference between the Value added (constant 2005 US$) of Iran in 2001 and the Value added (constant 2005 US$) of Turkmenistan in 2003?
Your response must be concise. 1.00e+1. What is the difference between the Value added (constant 2005 US$) in Middle income in 2001 and the Value added (constant 2005 US$) in Iceland in 2004?
Keep it short and to the point. 7.57e+11. What is the difference between the Value added (constant 2005 US$) of Middle income in 2001 and the Value added (constant 2005 US$) of Iran in 2004?
Keep it short and to the point. 7.45e+11. What is the difference between the Value added (constant 2005 US$) in Middle income in 2001 and the Value added (constant 2005 US$) in Turkmenistan in 2004?
Your answer should be very brief. 7.57e+11. What is the difference between the Value added (constant 2005 US$) of Iceland in 2001 and the Value added (constant 2005 US$) of Iran in 2004?
Your answer should be very brief. -1.24e+1. What is the difference between the Value added (constant 2005 US$) of Iceland in 2001 and the Value added (constant 2005 US$) of Turkmenistan in 2004?
Your answer should be compact. -4.57e+08. What is the difference between the Value added (constant 2005 US$) in Iran in 2001 and the Value added (constant 2005 US$) in Turkmenistan in 2004?
Provide a short and direct response. 9.82e+09. What is the difference between the Value added (constant 2005 US$) of Middle income in 2002 and the Value added (constant 2005 US$) of Iceland in 2003?
Give a very brief answer. 7.78e+11. What is the difference between the Value added (constant 2005 US$) in Middle income in 2002 and the Value added (constant 2005 US$) in Iran in 2003?
Keep it short and to the point. 7.66e+11. What is the difference between the Value added (constant 2005 US$) in Middle income in 2002 and the Value added (constant 2005 US$) in Turkmenistan in 2003?
Your response must be concise. 7.78e+11. What is the difference between the Value added (constant 2005 US$) in Iceland in 2002 and the Value added (constant 2005 US$) in Iran in 2003?
Keep it short and to the point. -1.24e+1. What is the difference between the Value added (constant 2005 US$) in Iceland in 2002 and the Value added (constant 2005 US$) in Turkmenistan in 2003?
Your answer should be very brief. -2.34e+08. What is the difference between the Value added (constant 2005 US$) in Iran in 2002 and the Value added (constant 2005 US$) in Turkmenistan in 2003?
Your response must be concise. 1.15e+1. What is the difference between the Value added (constant 2005 US$) in Middle income in 2002 and the Value added (constant 2005 US$) in Iceland in 2004?
Provide a short and direct response. 7.78e+11. What is the difference between the Value added (constant 2005 US$) in Middle income in 2002 and the Value added (constant 2005 US$) in Iran in 2004?
Your answer should be compact. 7.66e+11. What is the difference between the Value added (constant 2005 US$) in Middle income in 2002 and the Value added (constant 2005 US$) in Turkmenistan in 2004?
Your answer should be compact. 7.78e+11. What is the difference between the Value added (constant 2005 US$) in Iceland in 2002 and the Value added (constant 2005 US$) in Iran in 2004?
Your answer should be compact. -1.24e+1. What is the difference between the Value added (constant 2005 US$) in Iceland in 2002 and the Value added (constant 2005 US$) in Turkmenistan in 2004?
Offer a very short reply. -4.36e+08. What is the difference between the Value added (constant 2005 US$) in Iran in 2002 and the Value added (constant 2005 US$) in Turkmenistan in 2004?
Offer a very short reply. 1.13e+1. What is the difference between the Value added (constant 2005 US$) of Middle income in 2003 and the Value added (constant 2005 US$) of Iceland in 2004?
Your response must be concise. 8.13e+11. What is the difference between the Value added (constant 2005 US$) in Middle income in 2003 and the Value added (constant 2005 US$) in Iran in 2004?
Make the answer very short. 8.00e+11. What is the difference between the Value added (constant 2005 US$) in Middle income in 2003 and the Value added (constant 2005 US$) in Turkmenistan in 2004?
Provide a succinct answer. 8.12e+11. What is the difference between the Value added (constant 2005 US$) of Iceland in 2003 and the Value added (constant 2005 US$) of Iran in 2004?
Give a very brief answer. -1.24e+1. What is the difference between the Value added (constant 2005 US$) of Iceland in 2003 and the Value added (constant 2005 US$) of Turkmenistan in 2004?
Offer a very short reply. -4.61e+08. What is the difference between the Value added (constant 2005 US$) in Iran in 2003 and the Value added (constant 2005 US$) in Turkmenistan in 2004?
Your response must be concise. 1.19e+1. What is the average Value added (constant 2005 US$) of Middle income per year?
Keep it short and to the point. 7.55e+11. What is the average Value added (constant 2005 US$) in Iceland per year?
Provide a short and direct response. 8.08e+08. What is the average Value added (constant 2005 US$) of Iran per year?
Your answer should be very brief. 1.19e+1. What is the average Value added (constant 2005 US$) of Turkmenistan per year?
Keep it short and to the point. 8.75e+08. In the year 1997, what is the difference between the Value added (constant 2005 US$) in Middle income and Value added (constant 2005 US$) in Iceland?
Ensure brevity in your answer.  6.81e+11. In the year 1997, what is the difference between the Value added (constant 2005 US$) of Middle income and Value added (constant 2005 US$) of Iran?
Give a very brief answer. 6.71e+11. In the year 1997, what is the difference between the Value added (constant 2005 US$) of Middle income and Value added (constant 2005 US$) of Turkmenistan?
Provide a short and direct response. 6.82e+11. In the year 1997, what is the difference between the Value added (constant 2005 US$) in Iceland and Value added (constant 2005 US$) in Iran?
Keep it short and to the point. -9.81e+09. In the year 1997, what is the difference between the Value added (constant 2005 US$) of Iceland and Value added (constant 2005 US$) of Turkmenistan?
Provide a succinct answer. 3.98e+08. In the year 1997, what is the difference between the Value added (constant 2005 US$) of Iran and Value added (constant 2005 US$) of Turkmenistan?
Your answer should be very brief. 1.02e+1. In the year 1998, what is the difference between the Value added (constant 2005 US$) of Middle income and Value added (constant 2005 US$) of Iceland?
Your response must be concise. 7.03e+11. In the year 1998, what is the difference between the Value added (constant 2005 US$) of Middle income and Value added (constant 2005 US$) of Iran?
Offer a very short reply. 6.92e+11. In the year 1998, what is the difference between the Value added (constant 2005 US$) in Middle income and Value added (constant 2005 US$) in Turkmenistan?
Make the answer very short. 7.04e+11. In the year 1998, what is the difference between the Value added (constant 2005 US$) of Iceland and Value added (constant 2005 US$) of Iran?
Offer a very short reply. -1.10e+1. In the year 1998, what is the difference between the Value added (constant 2005 US$) in Iceland and Value added (constant 2005 US$) in Turkmenistan?
Your response must be concise. 2.40e+08. In the year 1998, what is the difference between the Value added (constant 2005 US$) in Iran and Value added (constant 2005 US$) in Turkmenistan?
Offer a terse response. 1.12e+1. In the year 1999, what is the difference between the Value added (constant 2005 US$) in Middle income and Value added (constant 2005 US$) in Iceland?
Your answer should be very brief. 7.21e+11. In the year 1999, what is the difference between the Value added (constant 2005 US$) of Middle income and Value added (constant 2005 US$) of Iran?
Your answer should be very brief. 7.10e+11. In the year 1999, what is the difference between the Value added (constant 2005 US$) in Middle income and Value added (constant 2005 US$) in Turkmenistan?
Your answer should be compact. 7.21e+11. In the year 1999, what is the difference between the Value added (constant 2005 US$) in Iceland and Value added (constant 2005 US$) in Iran?
Your response must be concise. -1.01e+1. In the year 1999, what is the difference between the Value added (constant 2005 US$) of Iceland and Value added (constant 2005 US$) of Turkmenistan?
Your answer should be compact. 7.12e+07. In the year 1999, what is the difference between the Value added (constant 2005 US$) in Iran and Value added (constant 2005 US$) in Turkmenistan?
Ensure brevity in your answer.  1.02e+1. In the year 2000, what is the difference between the Value added (constant 2005 US$) of Middle income and Value added (constant 2005 US$) of Iceland?
Provide a succinct answer. 7.34e+11. In the year 2000, what is the difference between the Value added (constant 2005 US$) in Middle income and Value added (constant 2005 US$) in Iran?
Offer a terse response. 7.24e+11. In the year 2000, what is the difference between the Value added (constant 2005 US$) of Middle income and Value added (constant 2005 US$) of Turkmenistan?
Your response must be concise. 7.34e+11. In the year 2000, what is the difference between the Value added (constant 2005 US$) in Iceland and Value added (constant 2005 US$) in Iran?
Provide a succinct answer. -1.05e+1. In the year 2000, what is the difference between the Value added (constant 2005 US$) in Iceland and Value added (constant 2005 US$) in Turkmenistan?
Your answer should be compact. -6.84e+07. In the year 2000, what is the difference between the Value added (constant 2005 US$) of Iran and Value added (constant 2005 US$) of Turkmenistan?
Ensure brevity in your answer.  1.05e+1. In the year 2001, what is the difference between the Value added (constant 2005 US$) in Middle income and Value added (constant 2005 US$) in Iceland?
Keep it short and to the point. 7.57e+11. In the year 2001, what is the difference between the Value added (constant 2005 US$) in Middle income and Value added (constant 2005 US$) in Iran?
Your answer should be compact. 7.47e+11. In the year 2001, what is the difference between the Value added (constant 2005 US$) of Middle income and Value added (constant 2005 US$) of Turkmenistan?
Provide a short and direct response. 7.57e+11. In the year 2001, what is the difference between the Value added (constant 2005 US$) of Iceland and Value added (constant 2005 US$) of Iran?
Give a very brief answer. -1.03e+1. In the year 2001, what is the difference between the Value added (constant 2005 US$) in Iceland and Value added (constant 2005 US$) in Turkmenistan?
Your answer should be compact. -2.53e+08. In the year 2001, what is the difference between the Value added (constant 2005 US$) of Iran and Value added (constant 2005 US$) of Turkmenistan?
Ensure brevity in your answer.  1.00e+1. In the year 2002, what is the difference between the Value added (constant 2005 US$) in Middle income and Value added (constant 2005 US$) in Iceland?
Make the answer very short. 7.78e+11. In the year 2002, what is the difference between the Value added (constant 2005 US$) of Middle income and Value added (constant 2005 US$) of Iran?
Provide a short and direct response. 7.67e+11. In the year 2002, what is the difference between the Value added (constant 2005 US$) of Middle income and Value added (constant 2005 US$) of Turkmenistan?
Offer a very short reply. 7.78e+11. In the year 2002, what is the difference between the Value added (constant 2005 US$) of Iceland and Value added (constant 2005 US$) of Iran?
Give a very brief answer. -1.18e+1. In the year 2002, what is the difference between the Value added (constant 2005 US$) of Iceland and Value added (constant 2005 US$) of Turkmenistan?
Your answer should be very brief. -2.33e+08. In the year 2002, what is the difference between the Value added (constant 2005 US$) in Iran and Value added (constant 2005 US$) in Turkmenistan?
Give a very brief answer. 1.15e+1. In the year 2003, what is the difference between the Value added (constant 2005 US$) in Middle income and Value added (constant 2005 US$) in Iceland?
Provide a short and direct response. 8.13e+11. In the year 2003, what is the difference between the Value added (constant 2005 US$) in Middle income and Value added (constant 2005 US$) in Iran?
Keep it short and to the point. 8.01e+11. In the year 2003, what is the difference between the Value added (constant 2005 US$) of Middle income and Value added (constant 2005 US$) of Turkmenistan?
Your answer should be compact. 8.13e+11. In the year 2003, what is the difference between the Value added (constant 2005 US$) in Iceland and Value added (constant 2005 US$) in Iran?
Provide a short and direct response. -1.24e+1. In the year 2003, what is the difference between the Value added (constant 2005 US$) in Iceland and Value added (constant 2005 US$) in Turkmenistan?
Offer a terse response. -2.59e+08. In the year 2003, what is the difference between the Value added (constant 2005 US$) of Iran and Value added (constant 2005 US$) of Turkmenistan?
Your response must be concise. 1.21e+1. In the year 2004, what is the difference between the Value added (constant 2005 US$) of Middle income and Value added (constant 2005 US$) of Iceland?
Your answer should be compact. 8.45e+11. In the year 2004, what is the difference between the Value added (constant 2005 US$) in Middle income and Value added (constant 2005 US$) in Iran?
Your answer should be compact. 8.32e+11. In the year 2004, what is the difference between the Value added (constant 2005 US$) in Middle income and Value added (constant 2005 US$) in Turkmenistan?
Your answer should be compact. 8.44e+11. In the year 2004, what is the difference between the Value added (constant 2005 US$) in Iceland and Value added (constant 2005 US$) in Iran?
Keep it short and to the point. -1.24e+1. In the year 2004, what is the difference between the Value added (constant 2005 US$) in Iceland and Value added (constant 2005 US$) in Turkmenistan?
Provide a succinct answer. -4.32e+08. In the year 2004, what is the difference between the Value added (constant 2005 US$) of Iran and Value added (constant 2005 US$) of Turkmenistan?
Provide a succinct answer. 1.20e+1. What is the ratio of the Value added (constant 2005 US$) in Middle income in 1997 to that in 1998?
Make the answer very short. 0.97. What is the ratio of the Value added (constant 2005 US$) in Iceland in 1997 to that in 1998?
Keep it short and to the point. 1.05. What is the ratio of the Value added (constant 2005 US$) in Iran in 1997 to that in 1998?
Offer a terse response. 0.9. What is the ratio of the Value added (constant 2005 US$) of Turkmenistan in 1997 to that in 1998?
Your response must be concise. 0.8. What is the ratio of the Value added (constant 2005 US$) in Middle income in 1997 to that in 1999?
Offer a very short reply. 0.95. What is the ratio of the Value added (constant 2005 US$) of Iceland in 1997 to that in 1999?
Make the answer very short. 1.08. What is the ratio of the Value added (constant 2005 US$) in Iran in 1997 to that in 1999?
Offer a terse response. 0.98. What is the ratio of the Value added (constant 2005 US$) in Turkmenistan in 1997 to that in 1999?
Provide a succinct answer. 0.64. What is the ratio of the Value added (constant 2005 US$) in Middle income in 1997 to that in 2000?
Your answer should be compact. 0.93. What is the ratio of the Value added (constant 2005 US$) in Iceland in 1997 to that in 2000?
Give a very brief answer. 1.11. What is the ratio of the Value added (constant 2005 US$) of Iran in 1997 to that in 2000?
Provide a short and direct response. 0.94. What is the ratio of the Value added (constant 2005 US$) in Turkmenistan in 1997 to that in 2000?
Offer a very short reply. 0.55. What is the ratio of the Value added (constant 2005 US$) of Middle income in 1997 to that in 2001?
Ensure brevity in your answer.  0.9. What is the ratio of the Value added (constant 2005 US$) in Iceland in 1997 to that in 2001?
Provide a succinct answer. 1.09. What is the ratio of the Value added (constant 2005 US$) of Iran in 1997 to that in 2001?
Make the answer very short. 0.96. What is the ratio of the Value added (constant 2005 US$) of Turkmenistan in 1997 to that in 2001?
Ensure brevity in your answer.  0.45. What is the ratio of the Value added (constant 2005 US$) in Middle income in 1997 to that in 2002?
Provide a succinct answer. 0.88. What is the ratio of the Value added (constant 2005 US$) in Iceland in 1997 to that in 2002?
Your response must be concise. 1.06. What is the ratio of the Value added (constant 2005 US$) in Iran in 1997 to that in 2002?
Your answer should be compact. 0.85. What is the ratio of the Value added (constant 2005 US$) in Turkmenistan in 1997 to that in 2002?
Offer a very short reply. 0.44. What is the ratio of the Value added (constant 2005 US$) in Middle income in 1997 to that in 2003?
Offer a terse response. 0.84. What is the ratio of the Value added (constant 2005 US$) in Iceland in 1997 to that in 2003?
Provide a succinct answer. 1.1. What is the ratio of the Value added (constant 2005 US$) of Iran in 1997 to that in 2003?
Keep it short and to the point. 0.81. What is the ratio of the Value added (constant 2005 US$) in Turkmenistan in 1997 to that in 2003?
Your response must be concise. 0.44. What is the ratio of the Value added (constant 2005 US$) in Middle income in 1997 to that in 2004?
Make the answer very short. 0.81. What is the ratio of the Value added (constant 2005 US$) in Iceland in 1997 to that in 2004?
Ensure brevity in your answer.  1.06. What is the ratio of the Value added (constant 2005 US$) of Iran in 1997 to that in 2004?
Your response must be concise. 0.81. What is the ratio of the Value added (constant 2005 US$) of Turkmenistan in 1997 to that in 2004?
Your answer should be compact. 0.37. What is the ratio of the Value added (constant 2005 US$) in Middle income in 1998 to that in 1999?
Offer a terse response. 0.98. What is the ratio of the Value added (constant 2005 US$) in Iceland in 1998 to that in 1999?
Provide a succinct answer. 1.03. What is the ratio of the Value added (constant 2005 US$) of Iran in 1998 to that in 1999?
Provide a succinct answer. 1.08. What is the ratio of the Value added (constant 2005 US$) of Turkmenistan in 1998 to that in 1999?
Ensure brevity in your answer.  0.8. What is the ratio of the Value added (constant 2005 US$) in Middle income in 1998 to that in 2000?
Your response must be concise. 0.96. What is the ratio of the Value added (constant 2005 US$) of Iceland in 1998 to that in 2000?
Your answer should be very brief. 1.05. What is the ratio of the Value added (constant 2005 US$) of Iran in 1998 to that in 2000?
Offer a terse response. 1.04. What is the ratio of the Value added (constant 2005 US$) in Turkmenistan in 1998 to that in 2000?
Make the answer very short. 0.68. What is the ratio of the Value added (constant 2005 US$) of Middle income in 1998 to that in 2001?
Your answer should be very brief. 0.93. What is the ratio of the Value added (constant 2005 US$) of Iceland in 1998 to that in 2001?
Keep it short and to the point. 1.03. What is the ratio of the Value added (constant 2005 US$) of Iran in 1998 to that in 2001?
Offer a terse response. 1.07. What is the ratio of the Value added (constant 2005 US$) of Turkmenistan in 1998 to that in 2001?
Provide a succinct answer. 0.55. What is the ratio of the Value added (constant 2005 US$) in Middle income in 1998 to that in 2002?
Offer a very short reply. 0.9. What is the ratio of the Value added (constant 2005 US$) in Iceland in 1998 to that in 2002?
Offer a terse response. 1.01. What is the ratio of the Value added (constant 2005 US$) of Iran in 1998 to that in 2002?
Provide a short and direct response. 0.94. What is the ratio of the Value added (constant 2005 US$) in Turkmenistan in 1998 to that in 2002?
Offer a very short reply. 0.55. What is the ratio of the Value added (constant 2005 US$) in Middle income in 1998 to that in 2003?
Provide a succinct answer. 0.87. What is the ratio of the Value added (constant 2005 US$) in Iceland in 1998 to that in 2003?
Give a very brief answer. 1.04. What is the ratio of the Value added (constant 2005 US$) of Iran in 1998 to that in 2003?
Ensure brevity in your answer.  0.9. What is the ratio of the Value added (constant 2005 US$) in Turkmenistan in 1998 to that in 2003?
Your response must be concise. 0.55. What is the ratio of the Value added (constant 2005 US$) in Middle income in 1998 to that in 2004?
Give a very brief answer. 0.83. What is the ratio of the Value added (constant 2005 US$) of Iran in 1998 to that in 2004?
Give a very brief answer. 0.89. What is the ratio of the Value added (constant 2005 US$) in Turkmenistan in 1998 to that in 2004?
Make the answer very short. 0.46. What is the ratio of the Value added (constant 2005 US$) of Middle income in 1999 to that in 2000?
Offer a terse response. 0.98. What is the ratio of the Value added (constant 2005 US$) in Iceland in 1999 to that in 2000?
Your answer should be compact. 1.02. What is the ratio of the Value added (constant 2005 US$) in Iran in 1999 to that in 2000?
Your answer should be very brief. 0.97. What is the ratio of the Value added (constant 2005 US$) of Turkmenistan in 1999 to that in 2000?
Your response must be concise. 0.85. What is the ratio of the Value added (constant 2005 US$) in Middle income in 1999 to that in 2001?
Offer a very short reply. 0.95. What is the ratio of the Value added (constant 2005 US$) in Iceland in 1999 to that in 2001?
Your response must be concise. 1.01. What is the ratio of the Value added (constant 2005 US$) of Turkmenistan in 1999 to that in 2001?
Offer a very short reply. 0.69. What is the ratio of the Value added (constant 2005 US$) of Middle income in 1999 to that in 2002?
Your answer should be compact. 0.93. What is the ratio of the Value added (constant 2005 US$) of Iceland in 1999 to that in 2002?
Provide a succinct answer. 0.98. What is the ratio of the Value added (constant 2005 US$) in Iran in 1999 to that in 2002?
Your answer should be very brief. 0.87. What is the ratio of the Value added (constant 2005 US$) in Turkmenistan in 1999 to that in 2002?
Your response must be concise. 0.69. What is the ratio of the Value added (constant 2005 US$) in Middle income in 1999 to that in 2003?
Your answer should be compact. 0.89. What is the ratio of the Value added (constant 2005 US$) of Iceland in 1999 to that in 2003?
Provide a short and direct response. 1.01. What is the ratio of the Value added (constant 2005 US$) of Iran in 1999 to that in 2003?
Your response must be concise. 0.83. What is the ratio of the Value added (constant 2005 US$) of Turkmenistan in 1999 to that in 2003?
Offer a very short reply. 0.69. What is the ratio of the Value added (constant 2005 US$) of Middle income in 1999 to that in 2004?
Keep it short and to the point. 0.85. What is the ratio of the Value added (constant 2005 US$) in Iceland in 1999 to that in 2004?
Offer a terse response. 0.98. What is the ratio of the Value added (constant 2005 US$) of Iran in 1999 to that in 2004?
Your answer should be compact. 0.83. What is the ratio of the Value added (constant 2005 US$) of Turkmenistan in 1999 to that in 2004?
Provide a short and direct response. 0.58. What is the ratio of the Value added (constant 2005 US$) of Middle income in 2000 to that in 2001?
Give a very brief answer. 0.97. What is the ratio of the Value added (constant 2005 US$) of Iceland in 2000 to that in 2001?
Offer a very short reply. 0.99. What is the ratio of the Value added (constant 2005 US$) in Iran in 2000 to that in 2001?
Ensure brevity in your answer.  1.02. What is the ratio of the Value added (constant 2005 US$) of Turkmenistan in 2000 to that in 2001?
Provide a succinct answer. 0.81. What is the ratio of the Value added (constant 2005 US$) in Middle income in 2000 to that in 2002?
Your answer should be compact. 0.94. What is the ratio of the Value added (constant 2005 US$) of Iceland in 2000 to that in 2002?
Provide a succinct answer. 0.96. What is the ratio of the Value added (constant 2005 US$) of Iran in 2000 to that in 2002?
Provide a short and direct response. 0.9. What is the ratio of the Value added (constant 2005 US$) of Turkmenistan in 2000 to that in 2002?
Your answer should be compact. 0.81. What is the ratio of the Value added (constant 2005 US$) in Middle income in 2000 to that in 2003?
Your answer should be very brief. 0.9. What is the ratio of the Value added (constant 2005 US$) in Iran in 2000 to that in 2003?
Keep it short and to the point. 0.86. What is the ratio of the Value added (constant 2005 US$) of Turkmenistan in 2000 to that in 2003?
Your response must be concise. 0.81. What is the ratio of the Value added (constant 2005 US$) in Middle income in 2000 to that in 2004?
Keep it short and to the point. 0.87. What is the ratio of the Value added (constant 2005 US$) of Iceland in 2000 to that in 2004?
Your answer should be very brief. 0.96. What is the ratio of the Value added (constant 2005 US$) in Iran in 2000 to that in 2004?
Offer a very short reply. 0.86. What is the ratio of the Value added (constant 2005 US$) of Turkmenistan in 2000 to that in 2004?
Ensure brevity in your answer.  0.68. What is the ratio of the Value added (constant 2005 US$) in Middle income in 2001 to that in 2002?
Offer a terse response. 0.97. What is the ratio of the Value added (constant 2005 US$) of Iceland in 2001 to that in 2002?
Keep it short and to the point. 0.97. What is the ratio of the Value added (constant 2005 US$) in Iran in 2001 to that in 2002?
Keep it short and to the point. 0.88. What is the ratio of the Value added (constant 2005 US$) of Middle income in 2001 to that in 2003?
Offer a very short reply. 0.93. What is the ratio of the Value added (constant 2005 US$) in Iran in 2001 to that in 2003?
Your response must be concise. 0.84. What is the ratio of the Value added (constant 2005 US$) of Turkmenistan in 2001 to that in 2003?
Provide a succinct answer. 1. What is the ratio of the Value added (constant 2005 US$) of Middle income in 2001 to that in 2004?
Offer a very short reply. 0.9. What is the ratio of the Value added (constant 2005 US$) in Iran in 2001 to that in 2004?
Ensure brevity in your answer.  0.84. What is the ratio of the Value added (constant 2005 US$) of Turkmenistan in 2001 to that in 2004?
Make the answer very short. 0.84. What is the ratio of the Value added (constant 2005 US$) in Middle income in 2002 to that in 2003?
Give a very brief answer. 0.96. What is the ratio of the Value added (constant 2005 US$) of Iceland in 2002 to that in 2003?
Your answer should be very brief. 1.03. What is the ratio of the Value added (constant 2005 US$) of Iran in 2002 to that in 2003?
Your response must be concise. 0.95. What is the ratio of the Value added (constant 2005 US$) in Middle income in 2002 to that in 2004?
Offer a terse response. 0.92. What is the ratio of the Value added (constant 2005 US$) of Iceland in 2002 to that in 2004?
Your response must be concise. 0.99. What is the ratio of the Value added (constant 2005 US$) in Iran in 2002 to that in 2004?
Provide a short and direct response. 0.95. What is the ratio of the Value added (constant 2005 US$) of Turkmenistan in 2002 to that in 2004?
Provide a short and direct response. 0.84. What is the ratio of the Value added (constant 2005 US$) in Middle income in 2003 to that in 2004?
Ensure brevity in your answer.  0.96. What is the ratio of the Value added (constant 2005 US$) of Iceland in 2003 to that in 2004?
Offer a terse response. 0.96. What is the ratio of the Value added (constant 2005 US$) in Turkmenistan in 2003 to that in 2004?
Your response must be concise. 0.84. What is the difference between the highest and the second highest Value added (constant 2005 US$) in Middle income?
Offer a terse response. 3.18e+1. What is the difference between the highest and the second highest Value added (constant 2005 US$) in Iceland?
Your answer should be compact. 4.45e+07. What is the difference between the highest and the second highest Value added (constant 2005 US$) in Iran?
Offer a terse response. 4.16e+07. What is the difference between the highest and the second highest Value added (constant 2005 US$) in Turkmenistan?
Your answer should be very brief. 2.02e+08. What is the difference between the highest and the lowest Value added (constant 2005 US$) in Middle income?
Provide a succinct answer. 1.64e+11. What is the difference between the highest and the lowest Value added (constant 2005 US$) in Iceland?
Offer a very short reply. 8.22e+07. What is the difference between the highest and the lowest Value added (constant 2005 US$) of Iran?
Offer a terse response. 2.55e+09. What is the difference between the highest and the lowest Value added (constant 2005 US$) in Turkmenistan?
Provide a short and direct response. 7.84e+08. 